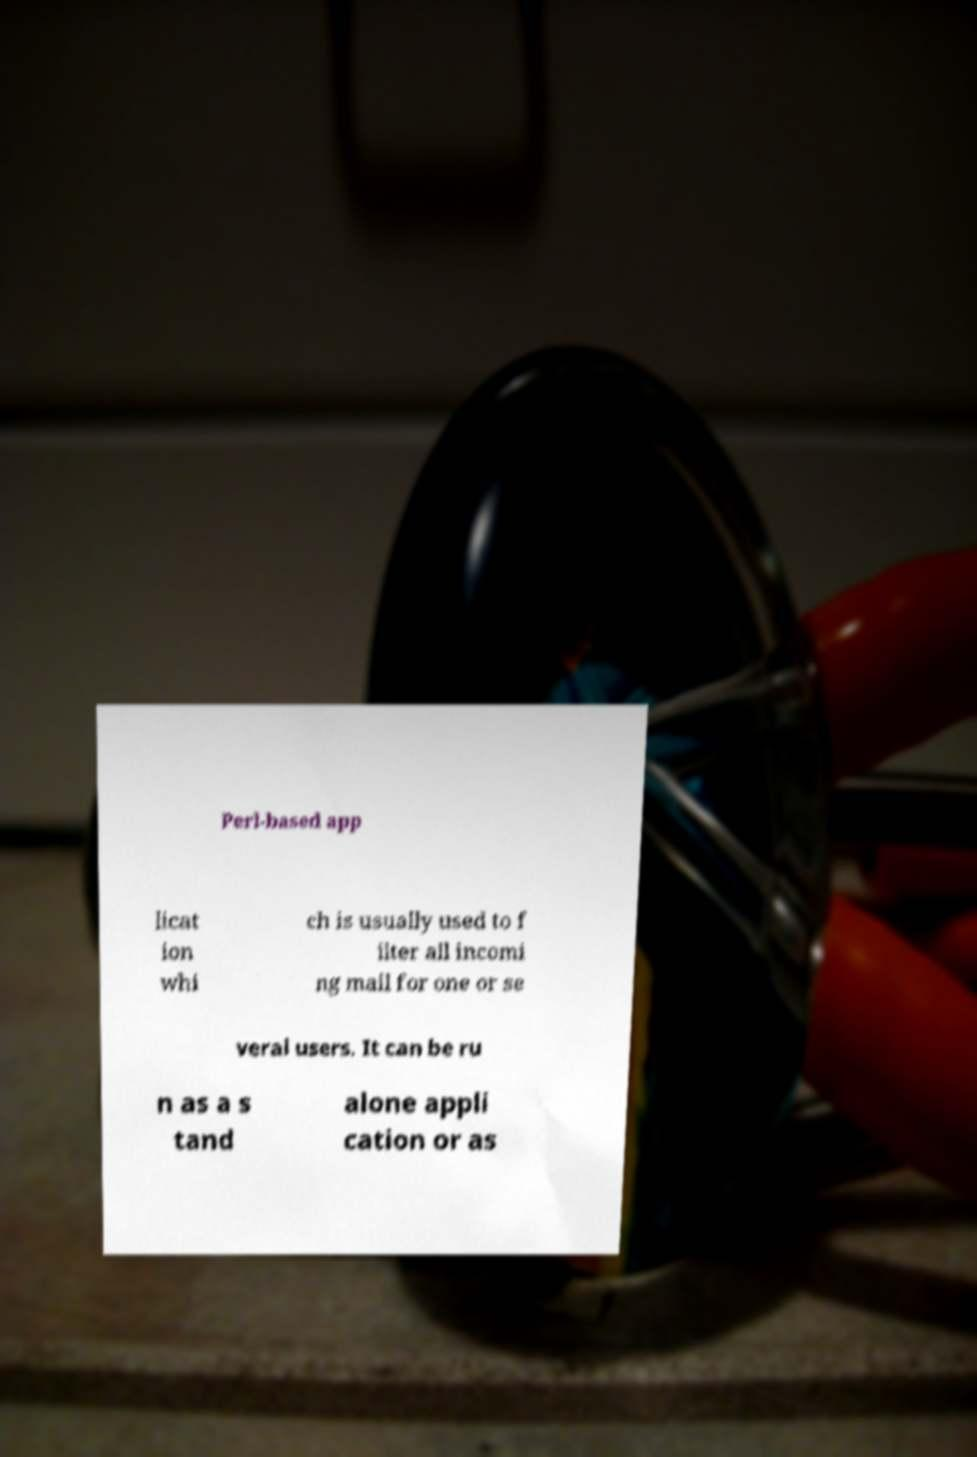Please identify and transcribe the text found in this image. Perl-based app licat ion whi ch is usually used to f ilter all incomi ng mail for one or se veral users. It can be ru n as a s tand alone appli cation or as 